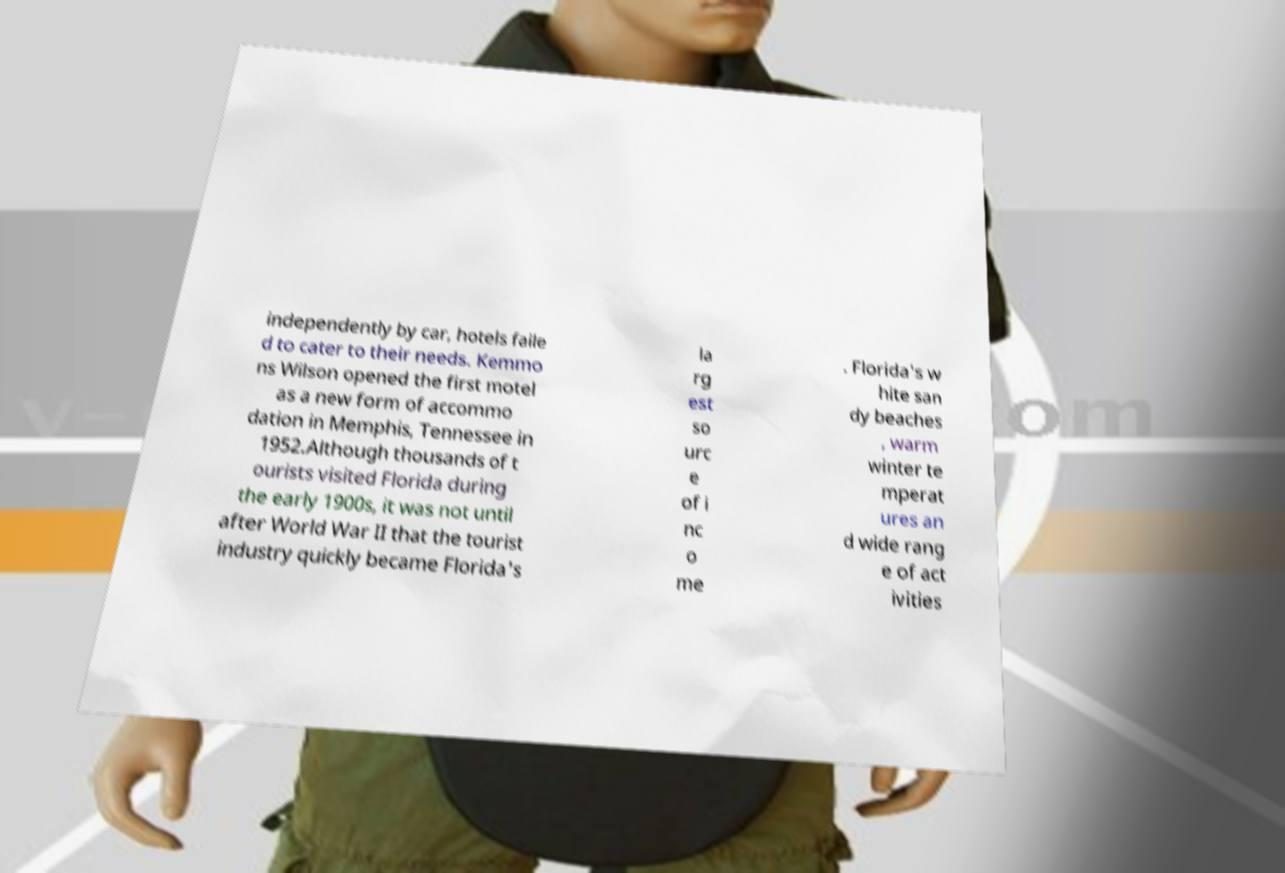Could you extract and type out the text from this image? independently by car, hotels faile d to cater to their needs. Kemmo ns Wilson opened the first motel as a new form of accommo dation in Memphis, Tennessee in 1952.Although thousands of t ourists visited Florida during the early 1900s, it was not until after World War II that the tourist industry quickly became Florida's la rg est so urc e of i nc o me . Florida's w hite san dy beaches , warm winter te mperat ures an d wide rang e of act ivities 